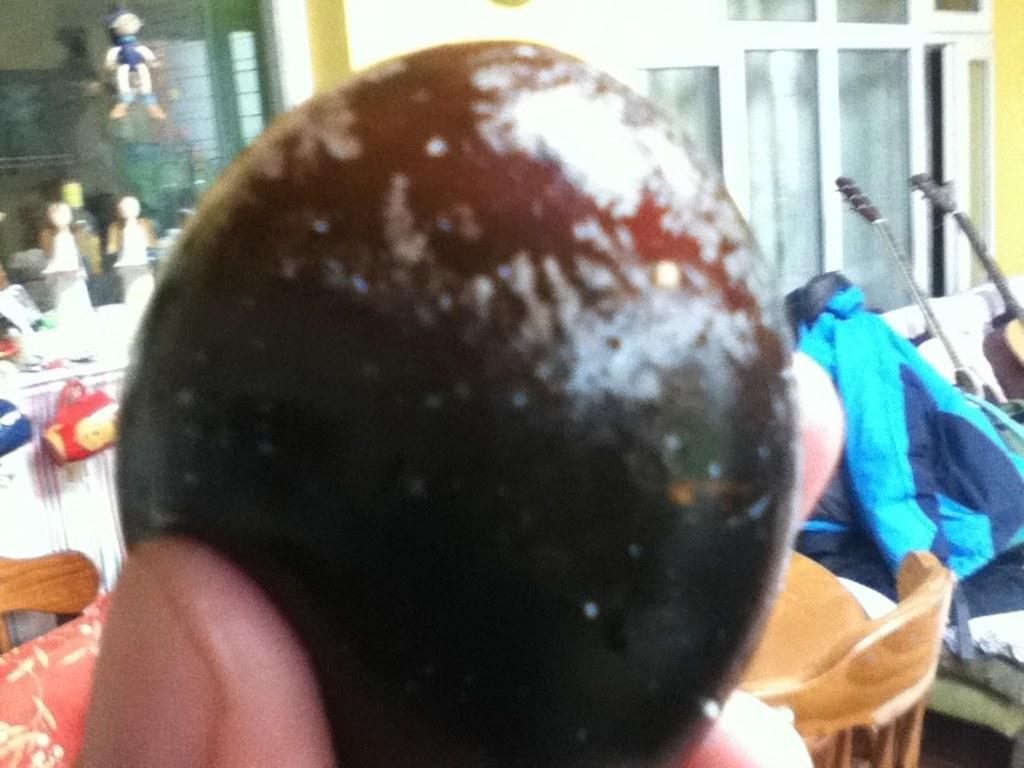Can you describe this image briefly? In this picture we can see a person holding an object and in the background we can see cars, toys, cup, cloth, guitar, windows, wall and some objects. 